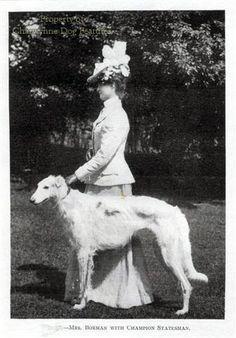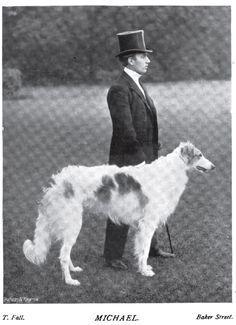The first image is the image on the left, the second image is the image on the right. Considering the images on both sides, is "There are only two dogs." valid? Answer yes or no. Yes. 